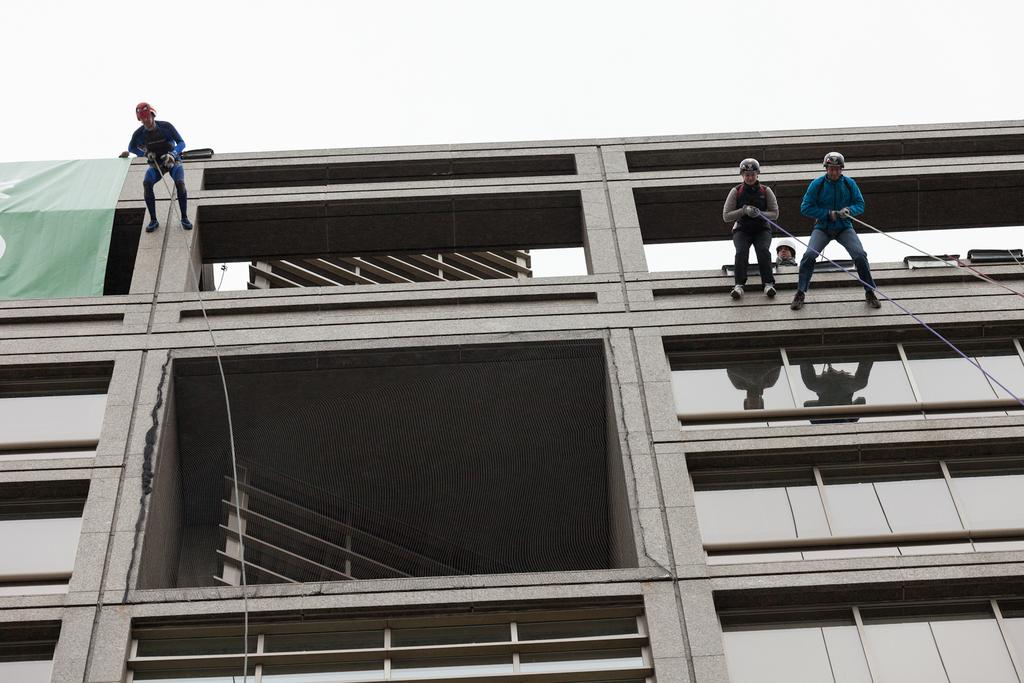How many people are in the image? There are 4 men in the image. Where are most of the men located in the image? Three of the men are on a building. How are the men on the building? The men are using ropes to be on the building. What type of bulb is being used by the men in the image? There is no mention of a bulb in the image, so it cannot be determined what type of bulb, if any, is being used. 